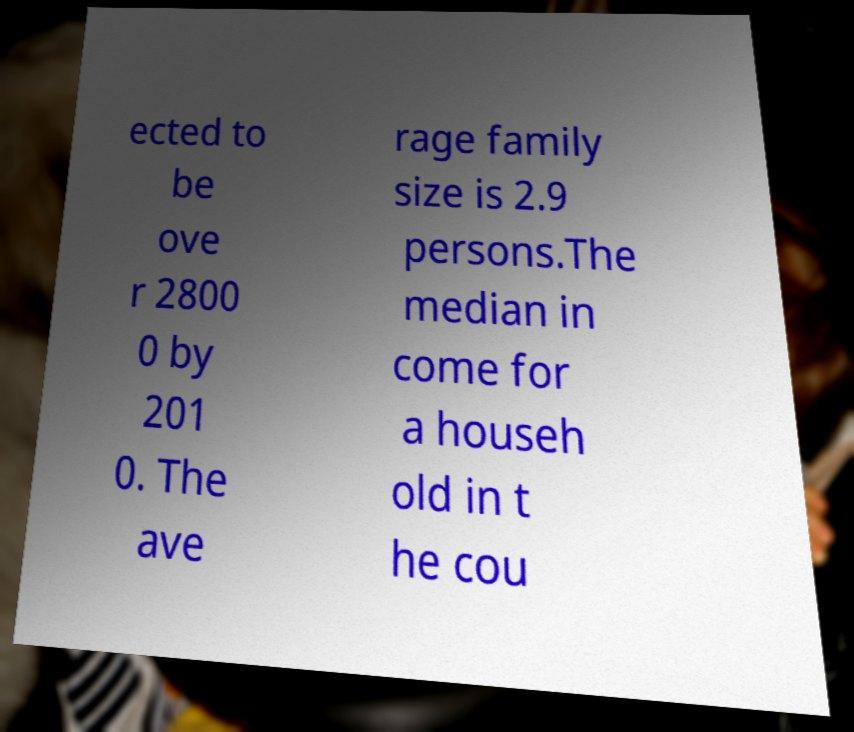Can you accurately transcribe the text from the provided image for me? ected to be ove r 2800 0 by 201 0. The ave rage family size is 2.9 persons.The median in come for a househ old in t he cou 